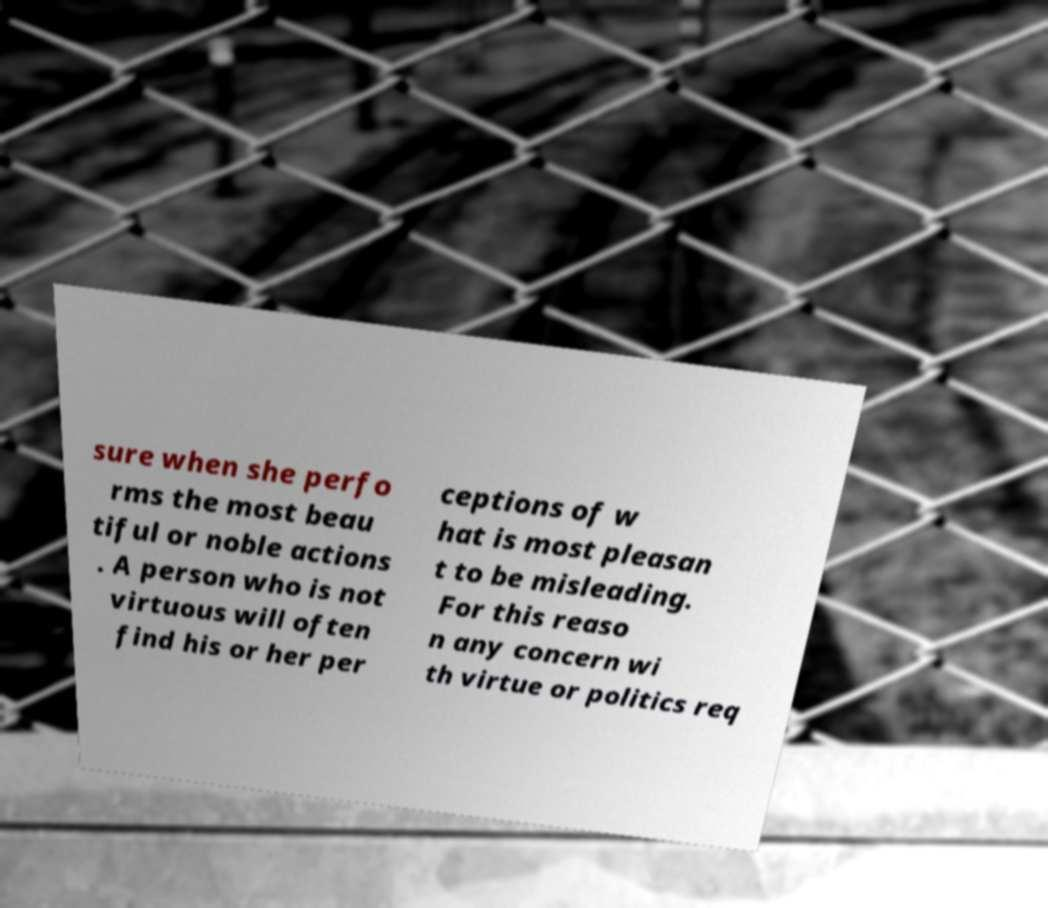For documentation purposes, I need the text within this image transcribed. Could you provide that? sure when she perfo rms the most beau tiful or noble actions . A person who is not virtuous will often find his or her per ceptions of w hat is most pleasan t to be misleading. For this reaso n any concern wi th virtue or politics req 